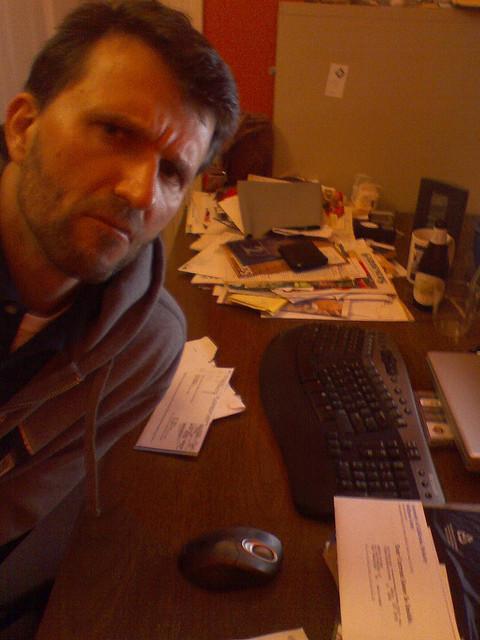How many of the papers in this photo look like bills?
Give a very brief answer. 2. How many cars are there?
Give a very brief answer. 0. 